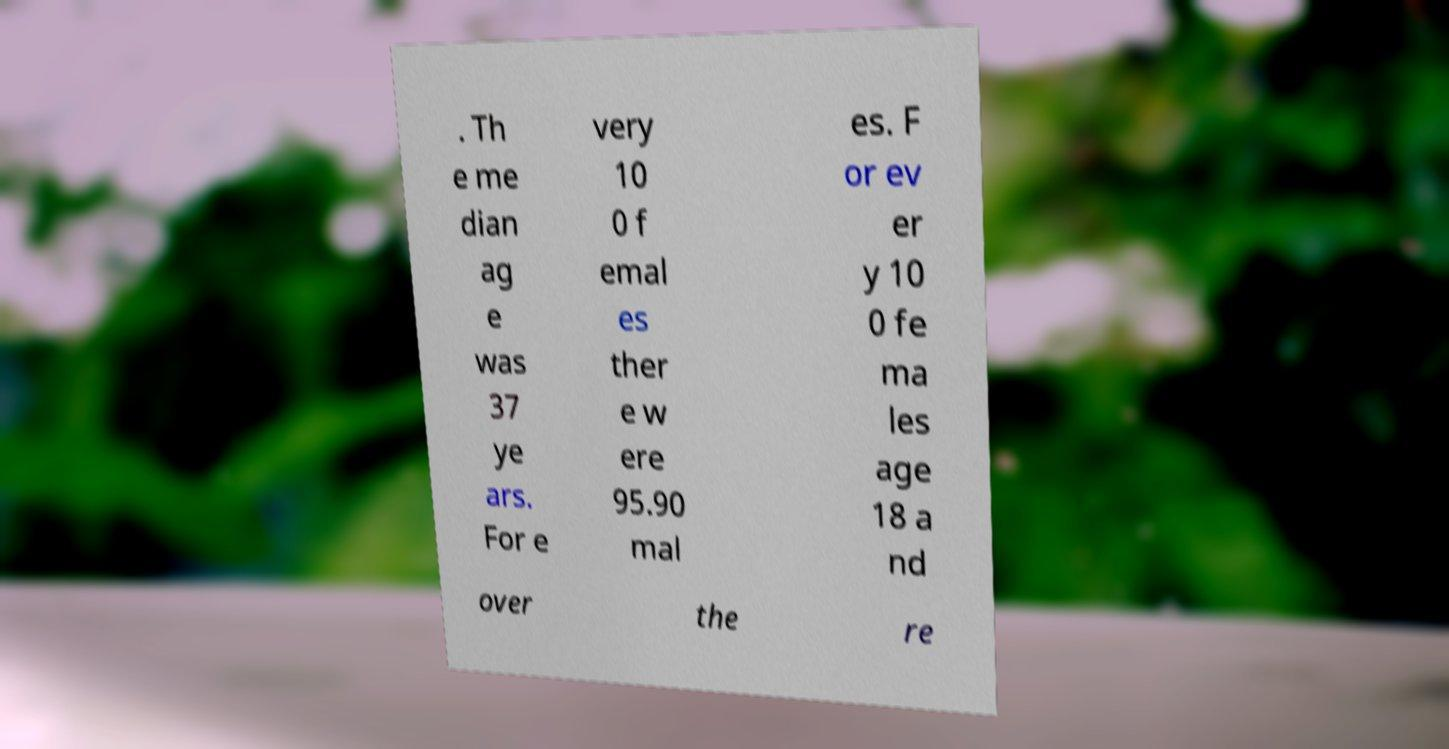Can you accurately transcribe the text from the provided image for me? . Th e me dian ag e was 37 ye ars. For e very 10 0 f emal es ther e w ere 95.90 mal es. F or ev er y 10 0 fe ma les age 18 a nd over the re 